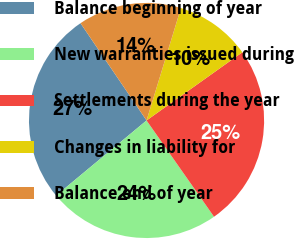Convert chart to OTSL. <chart><loc_0><loc_0><loc_500><loc_500><pie_chart><fcel>Balance beginning of year<fcel>New warranties issued during<fcel>Settlements during the year<fcel>Changes in liability for<fcel>Balance end of year<nl><fcel>26.54%<fcel>23.7%<fcel>25.12%<fcel>10.43%<fcel>14.22%<nl></chart> 